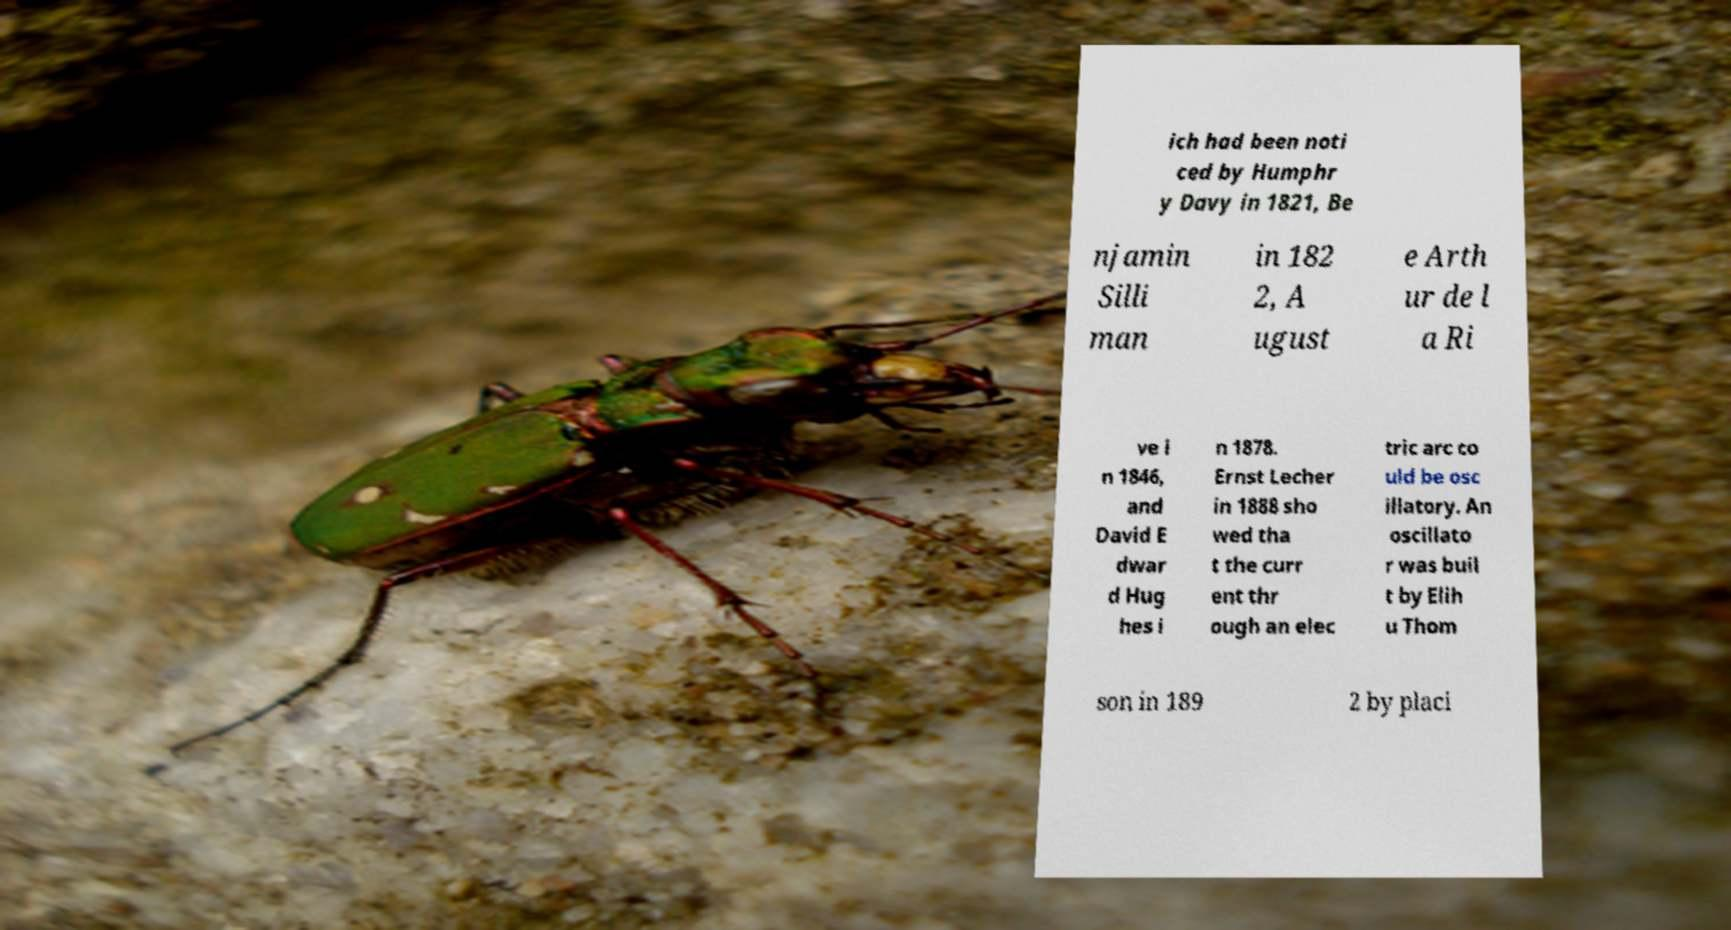Can you accurately transcribe the text from the provided image for me? ich had been noti ced by Humphr y Davy in 1821, Be njamin Silli man in 182 2, A ugust e Arth ur de l a Ri ve i n 1846, and David E dwar d Hug hes i n 1878. Ernst Lecher in 1888 sho wed tha t the curr ent thr ough an elec tric arc co uld be osc illatory. An oscillato r was buil t by Elih u Thom son in 189 2 by placi 